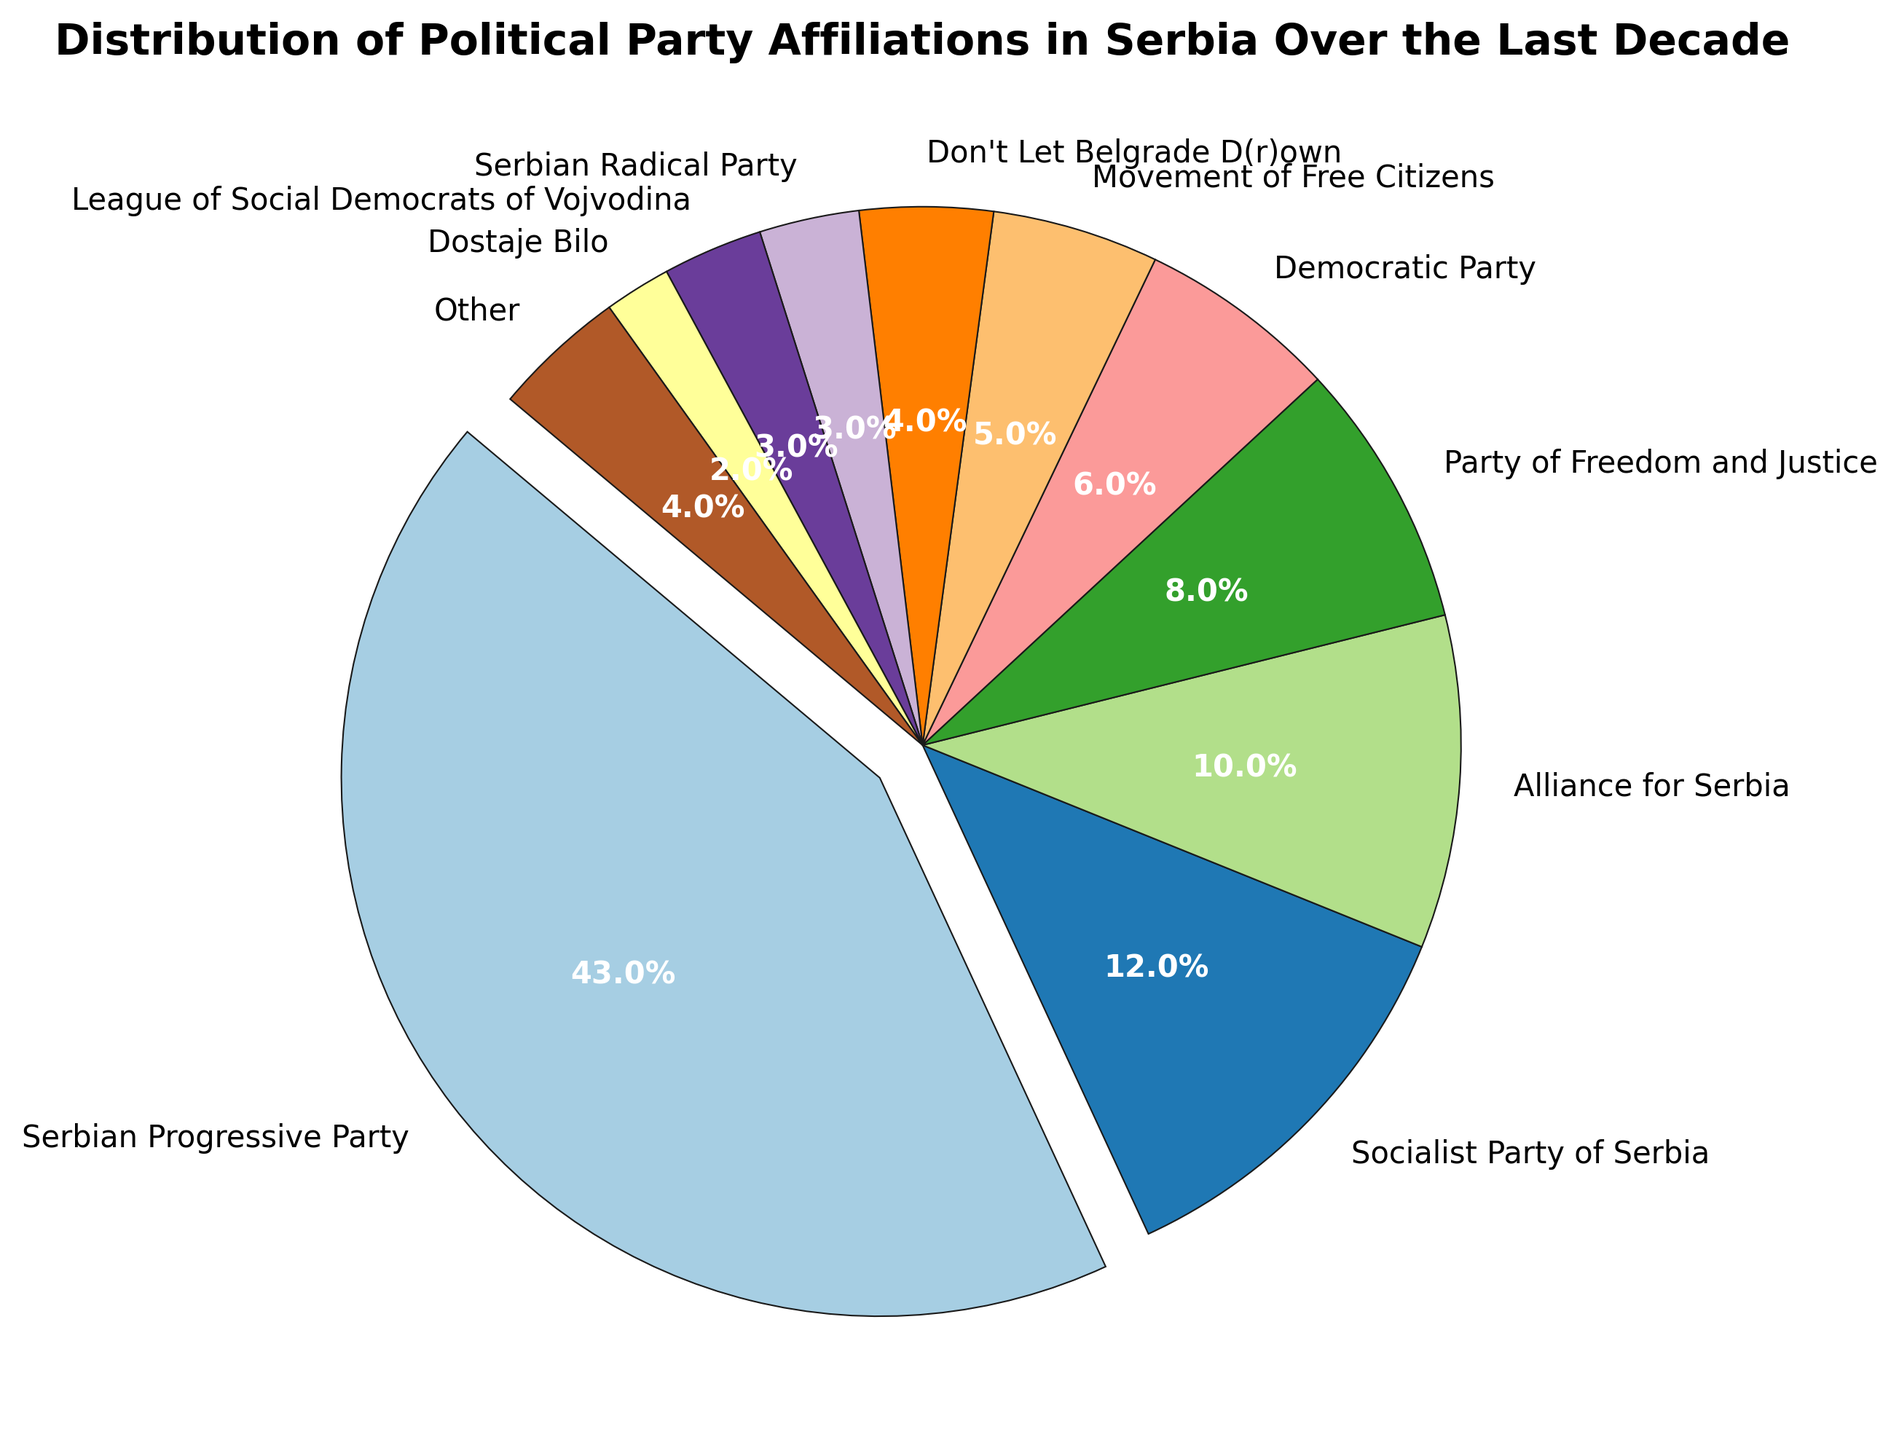What percentage of people are affiliated with the Serbian Progressive Party? The Serbian Progressive Party has a section on the pie chart labeled with its affiliation percentage. The label shows that their affiliation percentage is 43%.
Answer: 43% What is the combined affiliation percentage of the Socialist Party of Serbia and the Democratic Party? Add the affiliation percentages for the Socialist Party of Serbia (12%) and the Democratic Party (6%). 12% + 6% = 18%.
Answer: 18% Which party has the smallest affiliation percentage, and what is that percentage? The pie chart shows that Dostaje Bilo has the smallest section, labeled with an affiliation percentage of 2%.
Answer: Dostaje Bilo, 2% What is the total percentage for parties with single-digit representations? Sum the percentages of Party of Freedom and Justice (8%), Democratic Party (6%), Movement of Free Citizens (5%), Don't Let Belgrade D(r)own (4%), Serbian Radical Party (3%), League of Social Democrats of Vojvodina (3%), and Dostaje Bilo (2%). 8% + 6% + 5% + 4% + 3% + 3% + 2% = 31%.
Answer: 31% How does the affiliation of the Alliance for Serbia compare to the Movement of Free Citizens? The pie chart shows that the Alliance for Serbia has an affiliation percentage of 10%, while the Movement of Free Citizens has an affiliation percentage of 5%. 10% is greater than 5%.
Answer: The affiliation of the Alliance for Serbia (10%) is greater than the Movement of Free Citizens (5%) What affiliation percentage is represented by the 'Other' category, and how does it compare visually to the League of Social Democrats of Vojvodina? The 'Other' category has a section labeled with 4%. The League of Social Democrats of Vojvodina has a section labeled with 3%. Visually, the 'Other' section is slightly larger.
Answer: 'Other' 4%, larger than League of Social Democrats of Vojvodina 3% What percentage of the total does the top three parties represent? Summing the top three affiliation percentages: Serbian Progressive Party (43%), Socialist Party of Serbia (12%), and Alliance for Serbia (10%). 43% + 12% + 10% = 65%.
Answer: 65% How does the second-highest party's affiliation compare to the sum of the four smallest parties? The Socialist Party of Serbia is the second-highest with 12%. The four smallest parties are Serbian Radical Party (3%), League of Social Democrats of Vojvodina (3%), Dostaje Bilo (2%), and Don't Let Belgrade D(r)own (4%). Sum: 3% + 3% + 2% + 4% = 12%. 12% is equal to 12%.
Answer: Equal, both are 12% Identify the party with an affiliation percentage of 8% and describe its visual section on the pie chart. The Party of Freedom and Justice is labeled with 8%. Its section on the pie chart is a noticeable slice but smaller than the major sections such as the Serbian Progressive Party.
Answer: Party of Freedom and Justice, 8% Which parties have similar sizes in the chart, with each having 3% affiliation? The Serbian Radical Party and the League of Social Democrats of Vojvodina both have sections labeled with 3%. Their slices are of equal size.
Answer: Serbian Radical Party and League of Social Democrats of Vojvodina, both 3% 